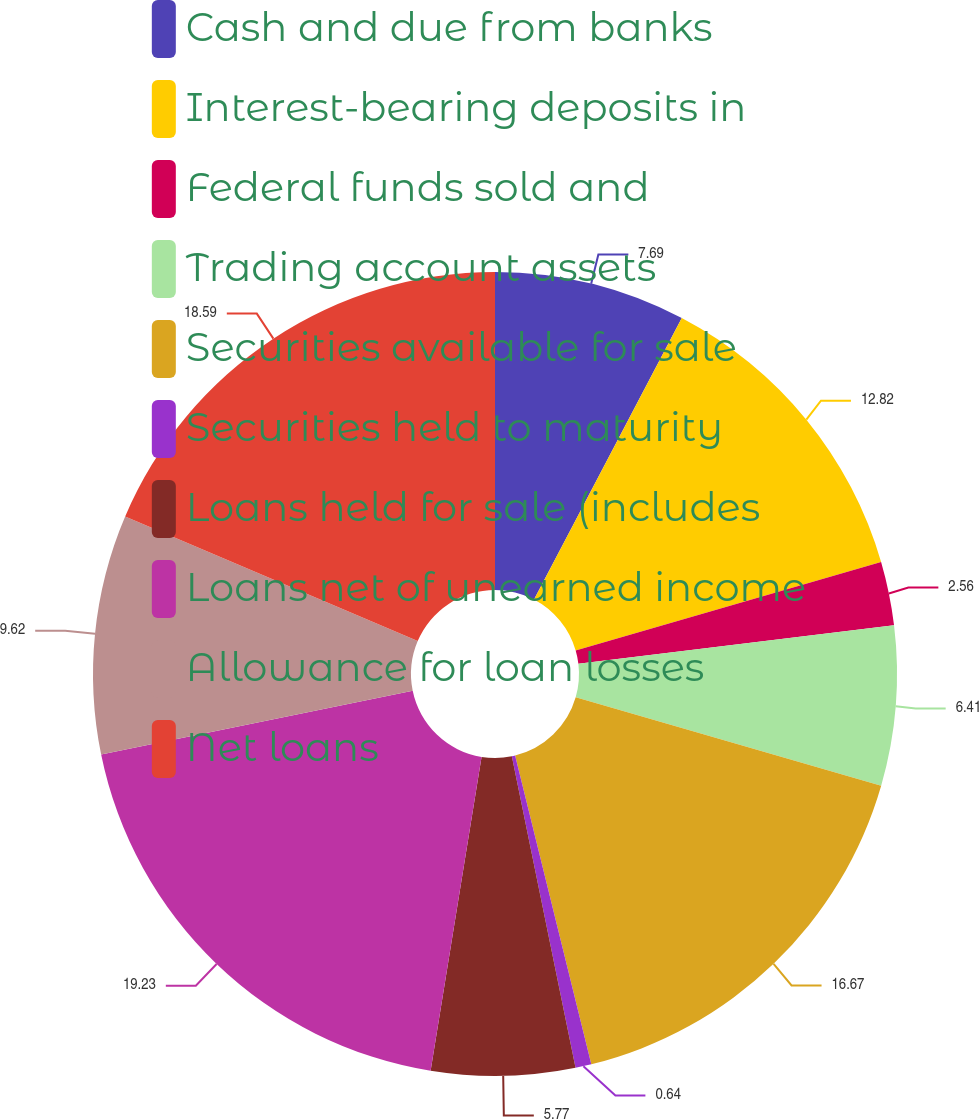<chart> <loc_0><loc_0><loc_500><loc_500><pie_chart><fcel>Cash and due from banks<fcel>Interest-bearing deposits in<fcel>Federal funds sold and<fcel>Trading account assets<fcel>Securities available for sale<fcel>Securities held to maturity<fcel>Loans held for sale (includes<fcel>Loans net of unearned income<fcel>Allowance for loan losses<fcel>Net loans<nl><fcel>7.69%<fcel>12.82%<fcel>2.56%<fcel>6.41%<fcel>16.67%<fcel>0.64%<fcel>5.77%<fcel>19.23%<fcel>9.62%<fcel>18.59%<nl></chart> 